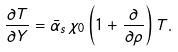Convert formula to latex. <formula><loc_0><loc_0><loc_500><loc_500>\frac { \partial T } { \partial Y } = \bar { \alpha } _ { s } \, \chi _ { 0 } \left ( 1 + \frac { \partial } { \partial \rho } \right ) T .</formula> 